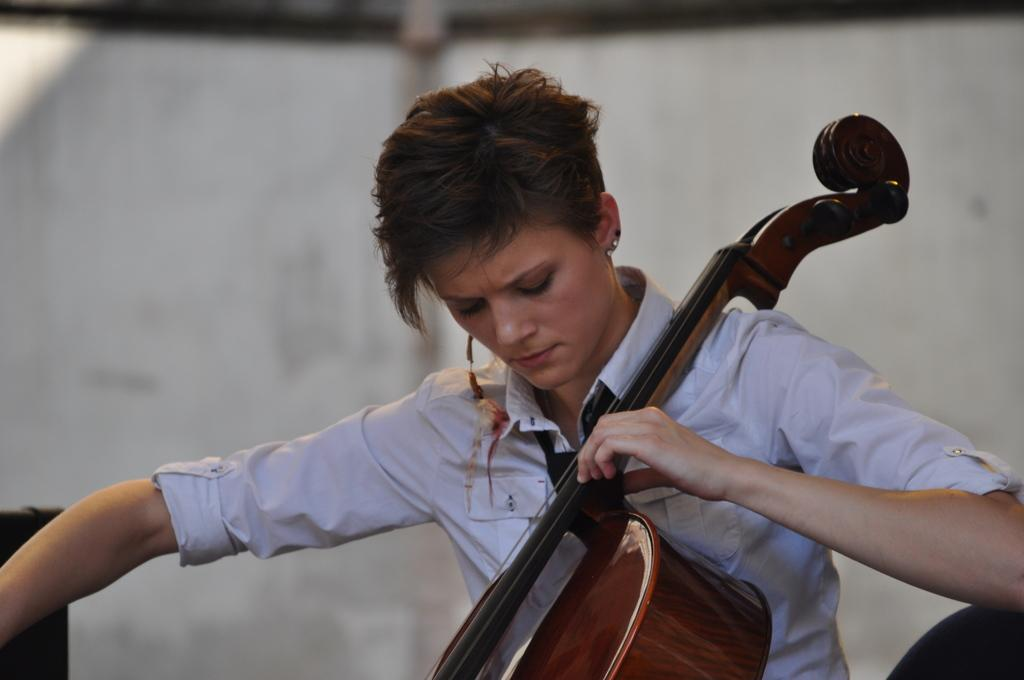Who is the main subject in the image? There is a woman in the image. What is the woman doing in the image? The woman is sitting in the image. What is the woman holding in the image? The woman is holding a musical instrument in the image. What can be seen behind the woman in the image? There is a wall behind the woman in the image. What is the purpose of the woman's transportation in the image? There is no transportation present in the image, as the woman is sitting and holding a musical instrument. 